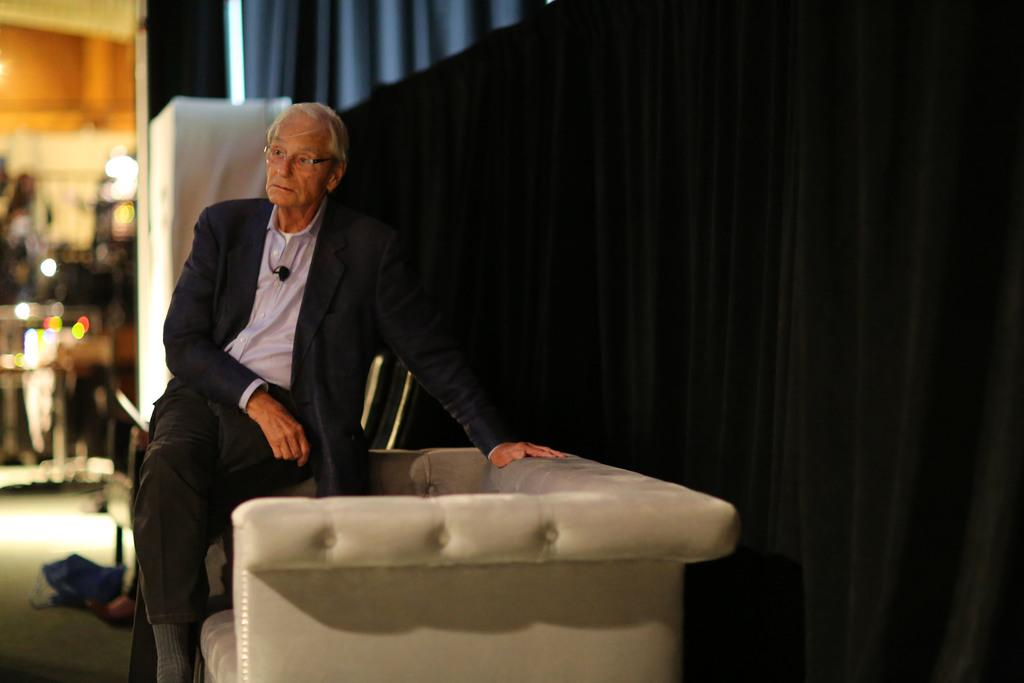What is the main subject of the image? There is a person in the image. What is the person wearing? The person is wearing a coat and spectacles. What is the person doing in the image? The person is sitting on a chair. Where is the chair located? The chair is placed on the floor. What can be seen in the background of the image? There are curtains in the background of the image. What type of news can be heard from the snails in the image? There are no snails present in the image, and therefore no news can be heard from them. What is the person's income in the image? The person's income is not mentioned or visible in the image. 